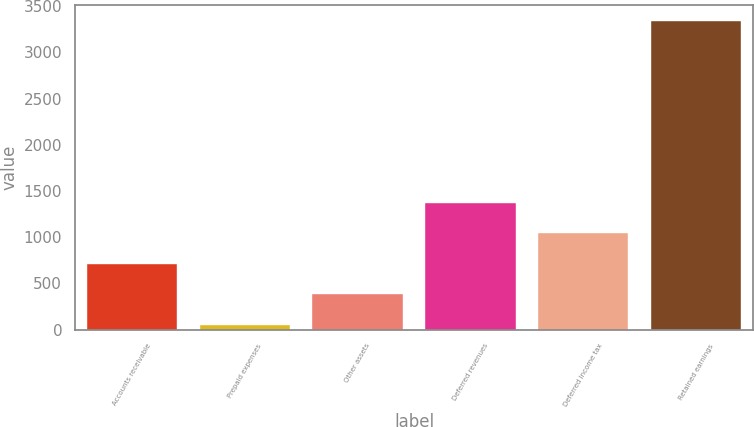Convert chart to OTSL. <chart><loc_0><loc_0><loc_500><loc_500><bar_chart><fcel>Accounts receivable<fcel>Prepaid expenses<fcel>Other assets<fcel>Deferred revenues<fcel>Deferred income tax<fcel>Retained earnings<nl><fcel>711.04<fcel>53<fcel>382.02<fcel>1369.08<fcel>1040.06<fcel>3343.2<nl></chart> 